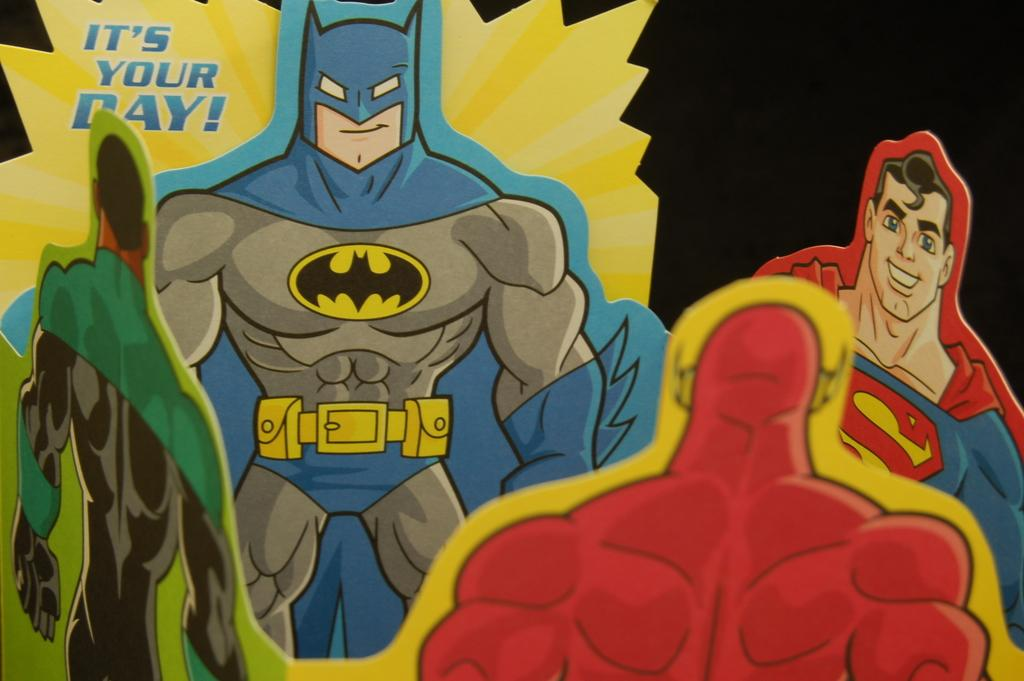What type of content is depicted in the image? There are cartoons in the image. What type of structure can be seen in the background of the cartoons? There is no background or structure present in the image, as it only contains cartoons. 